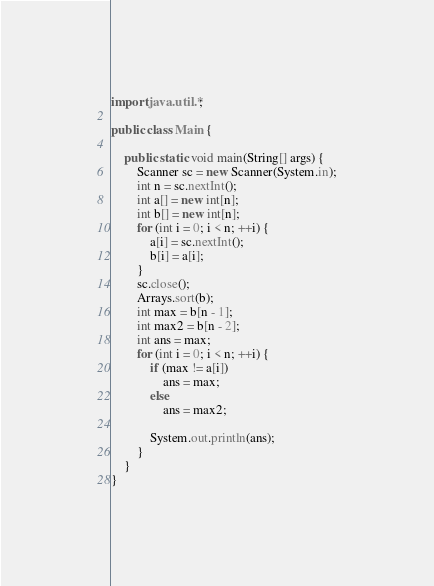<code> <loc_0><loc_0><loc_500><loc_500><_Java_>import java.util.*;

public class Main {

	public static void main(String[] args) {
		Scanner sc = new Scanner(System.in);
		int n = sc.nextInt();
		int a[] = new int[n];
		int b[] = new int[n];
		for (int i = 0; i < n; ++i) {
			a[i] = sc.nextInt();
			b[i] = a[i];
		}
		sc.close();
		Arrays.sort(b);
		int max = b[n - 1];
		int max2 = b[n - 2];
		int ans = max;
		for (int i = 0; i < n; ++i) {
			if (max != a[i])
				ans = max;
			else
				ans = max2;

			System.out.println(ans);
		}
	}
}
</code> 